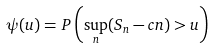Convert formula to latex. <formula><loc_0><loc_0><loc_500><loc_500>\psi ( u ) = P \left ( \sup _ { n } ( S _ { n } - c n ) > u \right )</formula> 